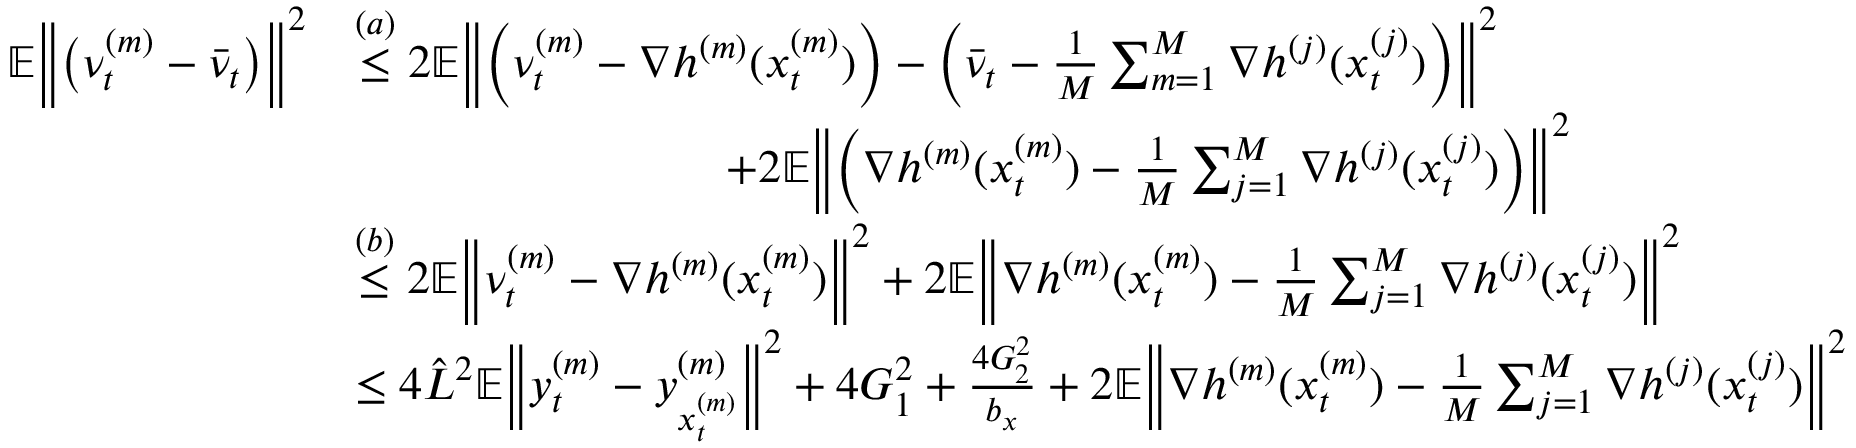<formula> <loc_0><loc_0><loc_500><loc_500>\begin{array} { r l } { \mathbb { E } \left \| \left ( \nu _ { t } ^ { ( m ) } - \bar { \nu } _ { t } \right ) \right \| ^ { 2 } } & { \overset { ( a ) } { \leq } 2 \mathbb { E } \left \| \left ( \nu _ { t } ^ { ( m ) } - \nabla h ^ { ( m ) } ( x _ { t } ^ { ( m ) } ) \right ) - \left ( \bar { \nu } _ { t } - \frac { 1 } { M } \sum _ { m = 1 } ^ { M } \nabla h ^ { ( j ) } ( x _ { t } ^ { ( j ) } ) \right ) \right \| ^ { 2 } } \\ & { \quad + 2 \mathbb { E } \left \| \left ( \nabla h ^ { ( m ) } ( x _ { t } ^ { ( m ) } ) - \frac { 1 } { M } \sum _ { j = 1 } ^ { M } \nabla h ^ { ( j ) } ( x _ { t } ^ { ( j ) } ) \right ) \right \| ^ { 2 } } \\ & { \overset { ( b ) } { \leq } 2 \mathbb { E } \left \| \nu _ { t } ^ { ( m ) } - \nabla h ^ { ( m ) } ( x _ { t } ^ { ( m ) } ) \right \| ^ { 2 } + 2 \mathbb { E } \left \| \nabla h ^ { ( m ) } ( x _ { t } ^ { ( m ) } ) - \frac { 1 } { M } \sum _ { j = 1 } ^ { M } \nabla h ^ { ( j ) } ( x _ { t } ^ { ( j ) } ) \right \| ^ { 2 } } \\ & { \leq 4 \hat { L } ^ { 2 } \mathbb { E } \left \| y _ { t } ^ { ( m ) } - y _ { x _ { t } ^ { ( m ) } } ^ { ( m ) } \right \| ^ { 2 } + 4 G _ { 1 } ^ { 2 } + \frac { 4 G _ { 2 } ^ { 2 } } { b _ { x } } + 2 \mathbb { E } \left \| \nabla h ^ { ( m ) } ( x _ { t } ^ { ( m ) } ) - \frac { 1 } { M } \sum _ { j = 1 } ^ { M } \nabla h ^ { ( j ) } ( x _ { t } ^ { ( j ) } ) \right \| ^ { 2 } } \end{array}</formula> 